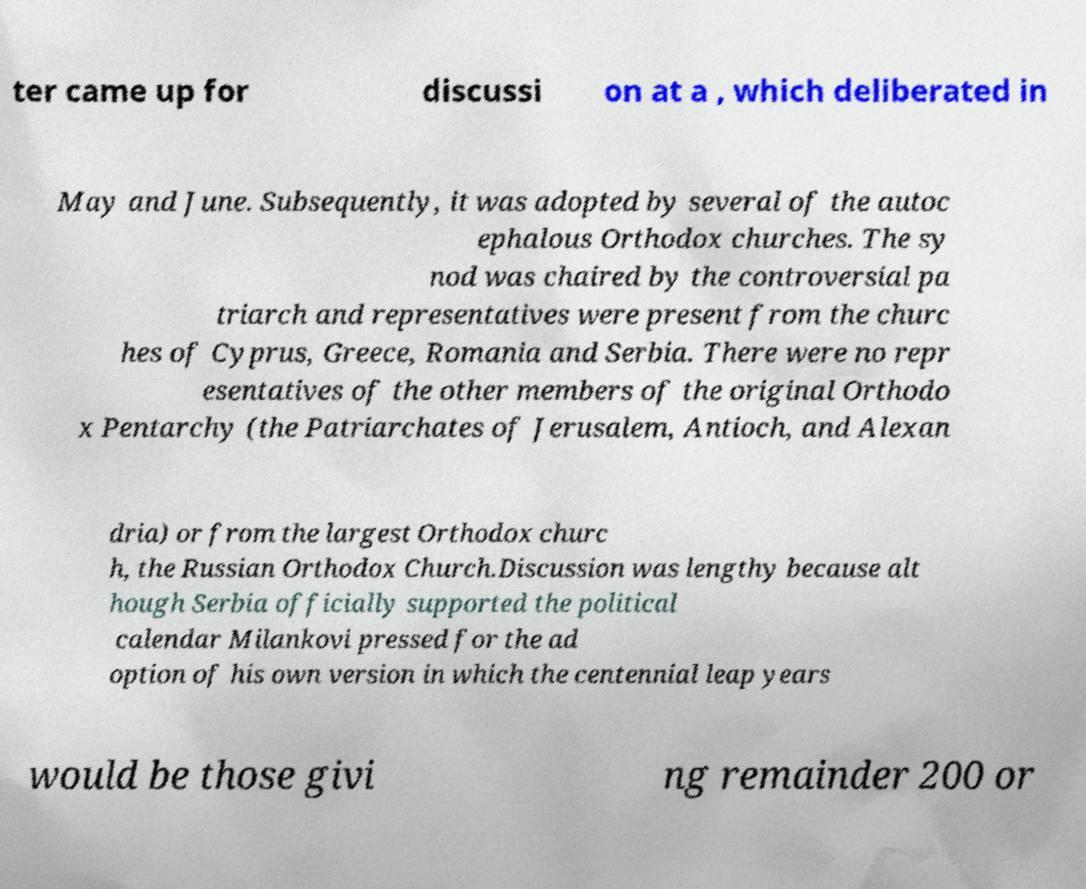Please read and relay the text visible in this image. What does it say? ter came up for discussi on at a , which deliberated in May and June. Subsequently, it was adopted by several of the autoc ephalous Orthodox churches. The sy nod was chaired by the controversial pa triarch and representatives were present from the churc hes of Cyprus, Greece, Romania and Serbia. There were no repr esentatives of the other members of the original Orthodo x Pentarchy (the Patriarchates of Jerusalem, Antioch, and Alexan dria) or from the largest Orthodox churc h, the Russian Orthodox Church.Discussion was lengthy because alt hough Serbia officially supported the political calendar Milankovi pressed for the ad option of his own version in which the centennial leap years would be those givi ng remainder 200 or 